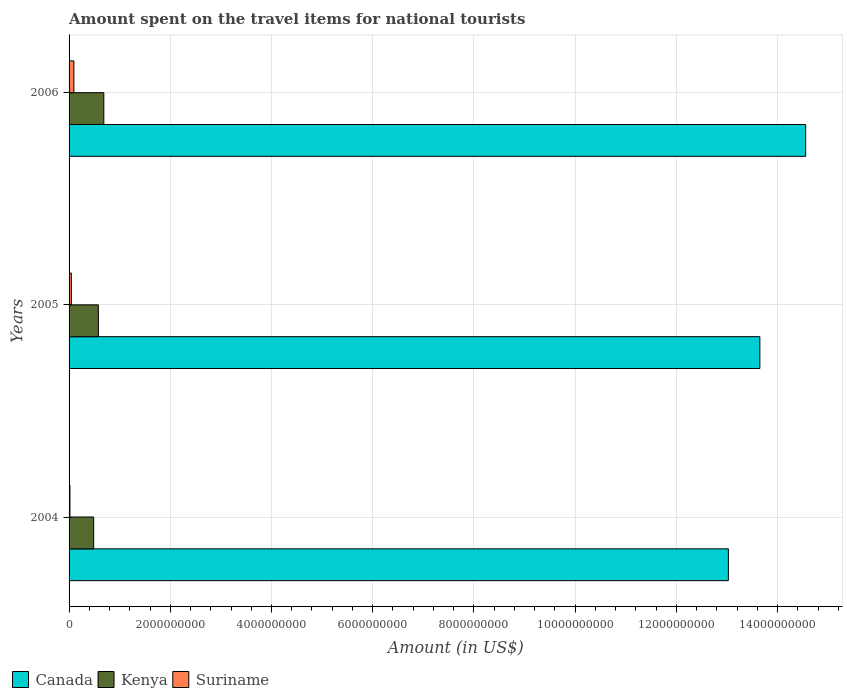How many groups of bars are there?
Keep it short and to the point. 3. Are the number of bars per tick equal to the number of legend labels?
Make the answer very short. Yes. In how many cases, is the number of bars for a given year not equal to the number of legend labels?
Offer a very short reply. 0. What is the amount spent on the travel items for national tourists in Canada in 2005?
Offer a terse response. 1.37e+1. Across all years, what is the maximum amount spent on the travel items for national tourists in Canada?
Your answer should be very brief. 1.46e+1. Across all years, what is the minimum amount spent on the travel items for national tourists in Suriname?
Make the answer very short. 1.70e+07. In which year was the amount spent on the travel items for national tourists in Kenya minimum?
Offer a terse response. 2004. What is the total amount spent on the travel items for national tourists in Kenya in the graph?
Make the answer very short. 1.75e+09. What is the difference between the amount spent on the travel items for national tourists in Kenya in 2004 and that in 2005?
Offer a terse response. -9.30e+07. What is the difference between the amount spent on the travel items for national tourists in Suriname in 2004 and the amount spent on the travel items for national tourists in Kenya in 2006?
Ensure brevity in your answer.  -6.70e+08. What is the average amount spent on the travel items for national tourists in Suriname per year?
Make the answer very short. 5.23e+07. In the year 2004, what is the difference between the amount spent on the travel items for national tourists in Canada and amount spent on the travel items for national tourists in Kenya?
Give a very brief answer. 1.25e+1. What is the ratio of the amount spent on the travel items for national tourists in Kenya in 2005 to that in 2006?
Provide a short and direct response. 0.84. Is the amount spent on the travel items for national tourists in Kenya in 2004 less than that in 2006?
Ensure brevity in your answer.  Yes. What is the difference between the highest and the second highest amount spent on the travel items for national tourists in Canada?
Ensure brevity in your answer.  9.05e+08. What is the difference between the highest and the lowest amount spent on the travel items for national tourists in Canada?
Ensure brevity in your answer.  1.53e+09. What does the 2nd bar from the top in 2004 represents?
Offer a very short reply. Kenya. How many years are there in the graph?
Make the answer very short. 3. Are the values on the major ticks of X-axis written in scientific E-notation?
Your response must be concise. No. Does the graph contain any zero values?
Provide a succinct answer. No. Does the graph contain grids?
Make the answer very short. Yes. Where does the legend appear in the graph?
Offer a terse response. Bottom left. How many legend labels are there?
Your answer should be compact. 3. What is the title of the graph?
Provide a succinct answer. Amount spent on the travel items for national tourists. What is the label or title of the Y-axis?
Ensure brevity in your answer.  Years. What is the Amount (in US$) in Canada in 2004?
Provide a succinct answer. 1.30e+1. What is the Amount (in US$) of Kenya in 2004?
Offer a very short reply. 4.86e+08. What is the Amount (in US$) of Suriname in 2004?
Your answer should be very brief. 1.70e+07. What is the Amount (in US$) of Canada in 2005?
Offer a terse response. 1.37e+1. What is the Amount (in US$) in Kenya in 2005?
Give a very brief answer. 5.79e+08. What is the Amount (in US$) of Suriname in 2005?
Make the answer very short. 4.50e+07. What is the Amount (in US$) of Canada in 2006?
Ensure brevity in your answer.  1.46e+1. What is the Amount (in US$) in Kenya in 2006?
Ensure brevity in your answer.  6.87e+08. What is the Amount (in US$) of Suriname in 2006?
Provide a succinct answer. 9.50e+07. Across all years, what is the maximum Amount (in US$) of Canada?
Make the answer very short. 1.46e+1. Across all years, what is the maximum Amount (in US$) of Kenya?
Your answer should be very brief. 6.87e+08. Across all years, what is the maximum Amount (in US$) of Suriname?
Provide a short and direct response. 9.50e+07. Across all years, what is the minimum Amount (in US$) in Canada?
Ensure brevity in your answer.  1.30e+1. Across all years, what is the minimum Amount (in US$) of Kenya?
Provide a succinct answer. 4.86e+08. Across all years, what is the minimum Amount (in US$) in Suriname?
Offer a very short reply. 1.70e+07. What is the total Amount (in US$) of Canada in the graph?
Offer a terse response. 4.12e+1. What is the total Amount (in US$) of Kenya in the graph?
Offer a very short reply. 1.75e+09. What is the total Amount (in US$) in Suriname in the graph?
Your response must be concise. 1.57e+08. What is the difference between the Amount (in US$) of Canada in 2004 and that in 2005?
Your answer should be very brief. -6.22e+08. What is the difference between the Amount (in US$) of Kenya in 2004 and that in 2005?
Provide a succinct answer. -9.30e+07. What is the difference between the Amount (in US$) of Suriname in 2004 and that in 2005?
Provide a short and direct response. -2.80e+07. What is the difference between the Amount (in US$) of Canada in 2004 and that in 2006?
Provide a short and direct response. -1.53e+09. What is the difference between the Amount (in US$) of Kenya in 2004 and that in 2006?
Keep it short and to the point. -2.01e+08. What is the difference between the Amount (in US$) in Suriname in 2004 and that in 2006?
Give a very brief answer. -7.80e+07. What is the difference between the Amount (in US$) of Canada in 2005 and that in 2006?
Make the answer very short. -9.05e+08. What is the difference between the Amount (in US$) of Kenya in 2005 and that in 2006?
Your response must be concise. -1.08e+08. What is the difference between the Amount (in US$) of Suriname in 2005 and that in 2006?
Your answer should be compact. -5.00e+07. What is the difference between the Amount (in US$) in Canada in 2004 and the Amount (in US$) in Kenya in 2005?
Provide a succinct answer. 1.24e+1. What is the difference between the Amount (in US$) of Canada in 2004 and the Amount (in US$) of Suriname in 2005?
Offer a very short reply. 1.30e+1. What is the difference between the Amount (in US$) in Kenya in 2004 and the Amount (in US$) in Suriname in 2005?
Provide a short and direct response. 4.41e+08. What is the difference between the Amount (in US$) in Canada in 2004 and the Amount (in US$) in Kenya in 2006?
Your response must be concise. 1.23e+1. What is the difference between the Amount (in US$) in Canada in 2004 and the Amount (in US$) in Suriname in 2006?
Your answer should be very brief. 1.29e+1. What is the difference between the Amount (in US$) of Kenya in 2004 and the Amount (in US$) of Suriname in 2006?
Provide a succinct answer. 3.91e+08. What is the difference between the Amount (in US$) in Canada in 2005 and the Amount (in US$) in Kenya in 2006?
Keep it short and to the point. 1.30e+1. What is the difference between the Amount (in US$) of Canada in 2005 and the Amount (in US$) of Suriname in 2006?
Offer a terse response. 1.36e+1. What is the difference between the Amount (in US$) in Kenya in 2005 and the Amount (in US$) in Suriname in 2006?
Keep it short and to the point. 4.84e+08. What is the average Amount (in US$) in Canada per year?
Give a very brief answer. 1.37e+1. What is the average Amount (in US$) of Kenya per year?
Ensure brevity in your answer.  5.84e+08. What is the average Amount (in US$) in Suriname per year?
Make the answer very short. 5.23e+07. In the year 2004, what is the difference between the Amount (in US$) of Canada and Amount (in US$) of Kenya?
Your answer should be compact. 1.25e+1. In the year 2004, what is the difference between the Amount (in US$) of Canada and Amount (in US$) of Suriname?
Offer a very short reply. 1.30e+1. In the year 2004, what is the difference between the Amount (in US$) in Kenya and Amount (in US$) in Suriname?
Provide a succinct answer. 4.69e+08. In the year 2005, what is the difference between the Amount (in US$) in Canada and Amount (in US$) in Kenya?
Provide a short and direct response. 1.31e+1. In the year 2005, what is the difference between the Amount (in US$) in Canada and Amount (in US$) in Suriname?
Keep it short and to the point. 1.36e+1. In the year 2005, what is the difference between the Amount (in US$) of Kenya and Amount (in US$) of Suriname?
Your answer should be compact. 5.34e+08. In the year 2006, what is the difference between the Amount (in US$) in Canada and Amount (in US$) in Kenya?
Give a very brief answer. 1.39e+1. In the year 2006, what is the difference between the Amount (in US$) of Canada and Amount (in US$) of Suriname?
Give a very brief answer. 1.45e+1. In the year 2006, what is the difference between the Amount (in US$) of Kenya and Amount (in US$) of Suriname?
Your answer should be compact. 5.92e+08. What is the ratio of the Amount (in US$) of Canada in 2004 to that in 2005?
Your answer should be very brief. 0.95. What is the ratio of the Amount (in US$) in Kenya in 2004 to that in 2005?
Provide a succinct answer. 0.84. What is the ratio of the Amount (in US$) in Suriname in 2004 to that in 2005?
Your answer should be very brief. 0.38. What is the ratio of the Amount (in US$) in Canada in 2004 to that in 2006?
Ensure brevity in your answer.  0.9. What is the ratio of the Amount (in US$) of Kenya in 2004 to that in 2006?
Provide a succinct answer. 0.71. What is the ratio of the Amount (in US$) in Suriname in 2004 to that in 2006?
Offer a terse response. 0.18. What is the ratio of the Amount (in US$) in Canada in 2005 to that in 2006?
Your answer should be compact. 0.94. What is the ratio of the Amount (in US$) of Kenya in 2005 to that in 2006?
Your response must be concise. 0.84. What is the ratio of the Amount (in US$) of Suriname in 2005 to that in 2006?
Offer a very short reply. 0.47. What is the difference between the highest and the second highest Amount (in US$) of Canada?
Your answer should be very brief. 9.05e+08. What is the difference between the highest and the second highest Amount (in US$) in Kenya?
Give a very brief answer. 1.08e+08. What is the difference between the highest and the second highest Amount (in US$) of Suriname?
Your answer should be compact. 5.00e+07. What is the difference between the highest and the lowest Amount (in US$) in Canada?
Your answer should be compact. 1.53e+09. What is the difference between the highest and the lowest Amount (in US$) in Kenya?
Provide a short and direct response. 2.01e+08. What is the difference between the highest and the lowest Amount (in US$) of Suriname?
Provide a short and direct response. 7.80e+07. 